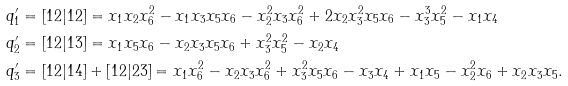Convert formula to latex. <formula><loc_0><loc_0><loc_500><loc_500>q _ { 1 } ^ { \prime } & = [ 1 2 | 1 2 ] = x _ { 1 } x _ { 2 } x _ { 6 } ^ { 2 } - x _ { 1 } x _ { 3 } x _ { 5 } x _ { 6 } - x _ { 2 } ^ { 2 } x _ { 3 } x _ { 6 } ^ { 2 } + 2 x _ { 2 } x _ { 3 } ^ { 2 } x _ { 5 } x _ { 6 } - x _ { 3 } ^ { 3 } x _ { 5 } ^ { 2 } - x _ { 1 } x _ { 4 } \\ q _ { 2 } ^ { \prime } & = [ 1 2 | 1 3 ] = x _ { 1 } x _ { 5 } x _ { 6 } - x _ { 2 } x _ { 3 } x _ { 5 } x _ { 6 } + x _ { 3 } ^ { 2 } x _ { 5 } ^ { 2 } - x _ { 2 } x _ { 4 } \\ q _ { 3 } ^ { \prime } & = [ 1 2 | 1 4 ] + [ 1 2 | 2 3 ] = x _ { 1 } x _ { 6 } ^ { 2 } - x _ { 2 } x _ { 3 } x _ { 6 } ^ { 2 } + x _ { 3 } ^ { 2 } x _ { 5 } x _ { 6 } - x _ { 3 } x _ { 4 } + x _ { 1 } x _ { 5 } - x _ { 2 } ^ { 2 } x _ { 6 } + x _ { 2 } x _ { 3 } x _ { 5 } .</formula> 